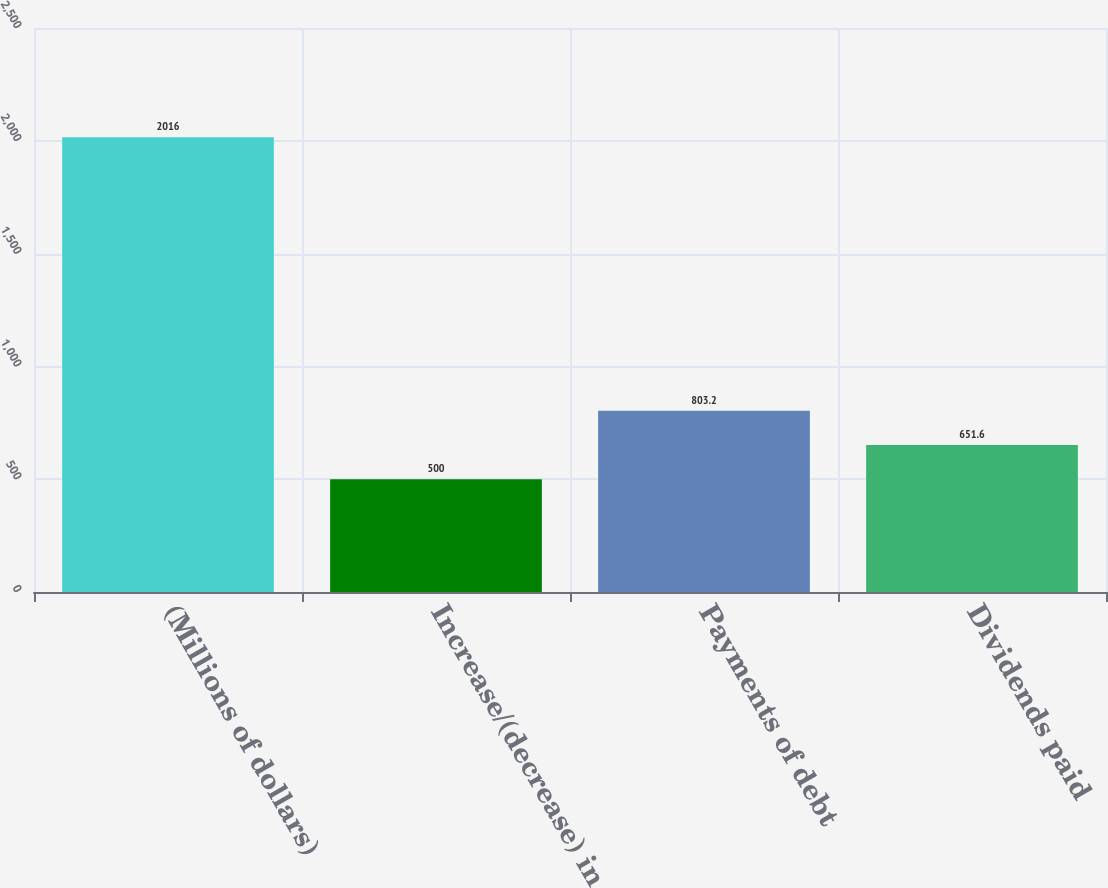Convert chart to OTSL. <chart><loc_0><loc_0><loc_500><loc_500><bar_chart><fcel>(Millions of dollars)<fcel>Increase/(decrease) in<fcel>Payments of debt<fcel>Dividends paid<nl><fcel>2016<fcel>500<fcel>803.2<fcel>651.6<nl></chart> 